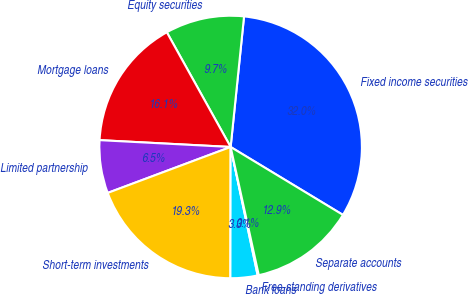<chart> <loc_0><loc_0><loc_500><loc_500><pie_chart><fcel>Fixed income securities<fcel>Equity securities<fcel>Mortgage loans<fcel>Limited partnership<fcel>Short-term investments<fcel>Bank loans<fcel>Free-standing derivatives<fcel>Separate accounts<nl><fcel>32.03%<fcel>9.71%<fcel>16.09%<fcel>6.52%<fcel>19.28%<fcel>3.33%<fcel>0.14%<fcel>12.9%<nl></chart> 